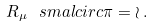<formula> <loc_0><loc_0><loc_500><loc_500>R _ { \mu } \ s m a l c i r c \pi = \wr \, .</formula> 